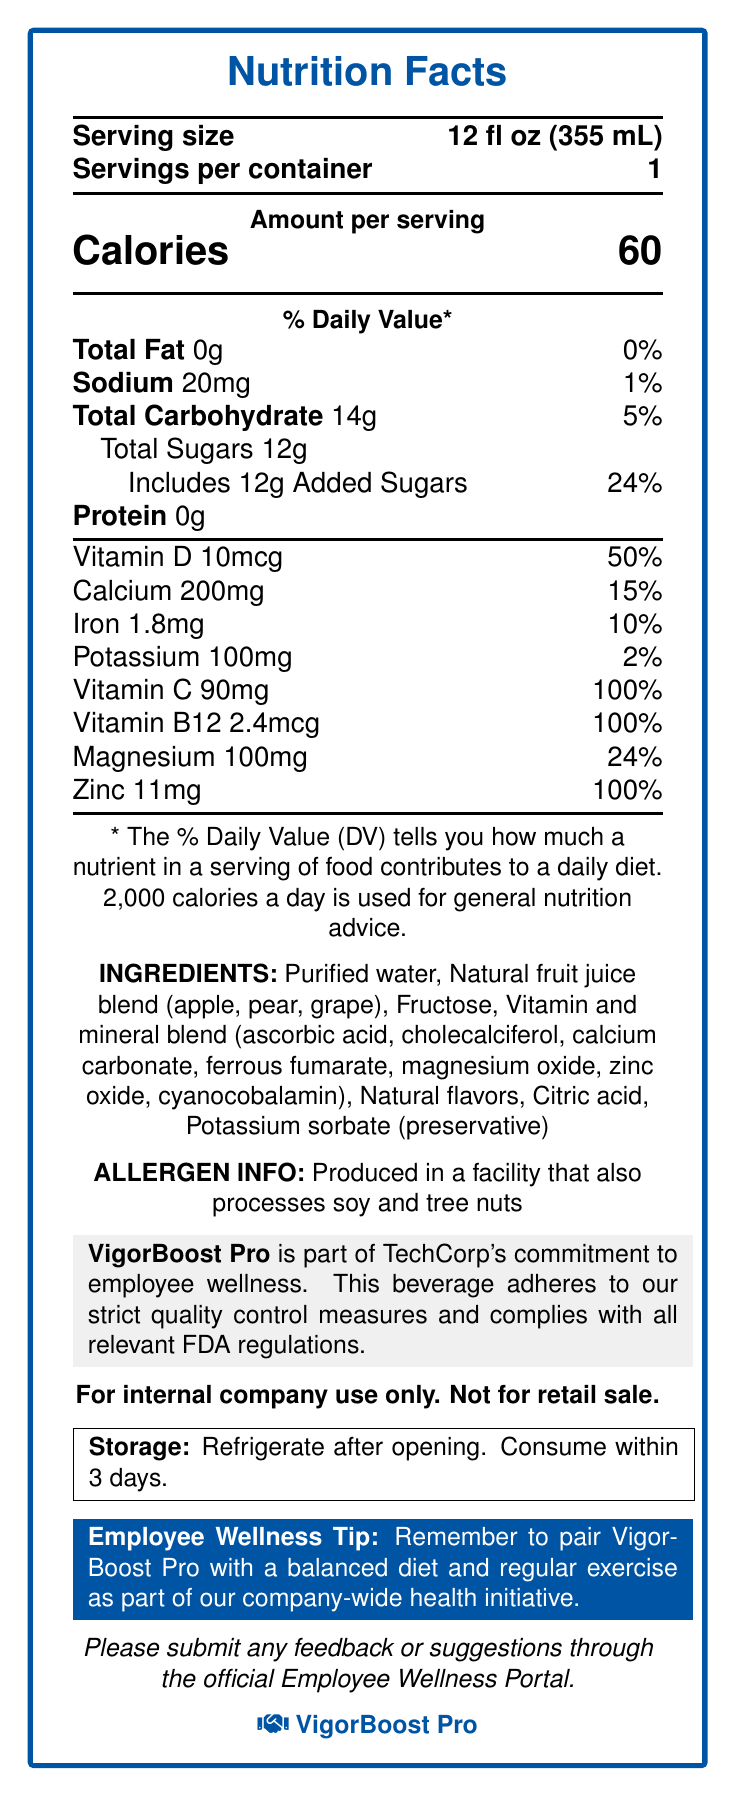what is the serving size? The serving size is listed at the top of the nutrition facts section under "Serving size".
Answer: 12 fl oz (355 mL) how many calories are in one serving? The total calories for one serving are shown prominently under the "Amount per serving" section.
Answer: 60 how much sodium does VigorBoost Pro contain per serving? Sodium content per serving is listed in the nutrition facts under "Sodium".
Answer: 20mg what is the total amount of carbohydrates per serving? The total carbohydrate amount per serving is shown in the nutrition facts section under "Total Carbohydrate".
Answer: 14g how much protein is present in one serving of VigorBoost Pro? The protein content per serving is listed as 0g in the nutrition facts section.
Answer: 0g what percentage of the daily value does the included added sugars contribute? The % Daily Value for added sugars is specified in the nutrition facts under "Includes 12g Added Sugars".
Answer: 24% how many vitamins and minerals contribute to 100% of their daily value? Vitamin C, Vitamin B12, and Zinc all provide 100% of their daily values, as shown in the nutrition facts section.
Answer: 4 what are the primary ingredients in VigorBoost Pro? A. Purified water, Fructose, Natural flavors B. Purified water, Natural fruit juice blend, Fructose C. Purified water, Natural fruit juice blend, Citric Acid D. Natural fruit juice blend, Fructose, Water The primary ingredients listed are Purified water, Natural fruit juice blend, and Fructose.
Answer: B which nutrient has the highest daily value percentage? I. Calcium II. Vitamin D III. Magnesium IV. Vitamin C Vitamin C has the highest daily value percentage listed at 100%.
Answer: IV is VigorBoost Pro for retail sale? Yes/No The document clearly states that it is "For internal company use only. Not for retail sale."
Answer: No describe the entire document. The document provides comprehensive nutritional details, ingredients, allergen information, and a company statement for the health-focused beverage VigorBoost Pro, emphasizing its contribution to employee wellness and company policies, and storage instructions.
Answer: The document is a detailed nutrition facts sheet for "VigorBoost Pro," a vitamin-enriched beverage. It includes information on serving size, nutritional content (calories, fats, sugars, carbohydrates, proteins, and various vitamins and minerals), ingredients, allergen information, storage instructions, a wellness tip, a statement of quality and compliance by TechCorp, and a note that the beverage is for internal use only. Additionally, it encourages employees to submit feedback through the Employee Wellness Portal. what other products are made in the facility where VigorBoost Pro is produced? The document states that it is produced in a facility that also processes soy and tree nuts but does not specify any other products made in the facility.
Answer: Not enough information 